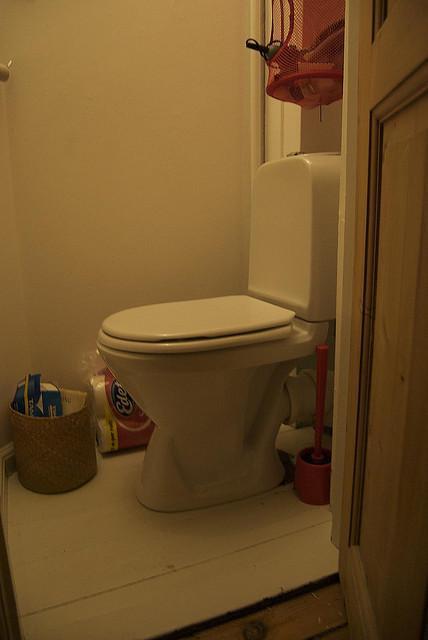How many rugs are there?
Give a very brief answer. 0. How many toilets are there?
Give a very brief answer. 1. 